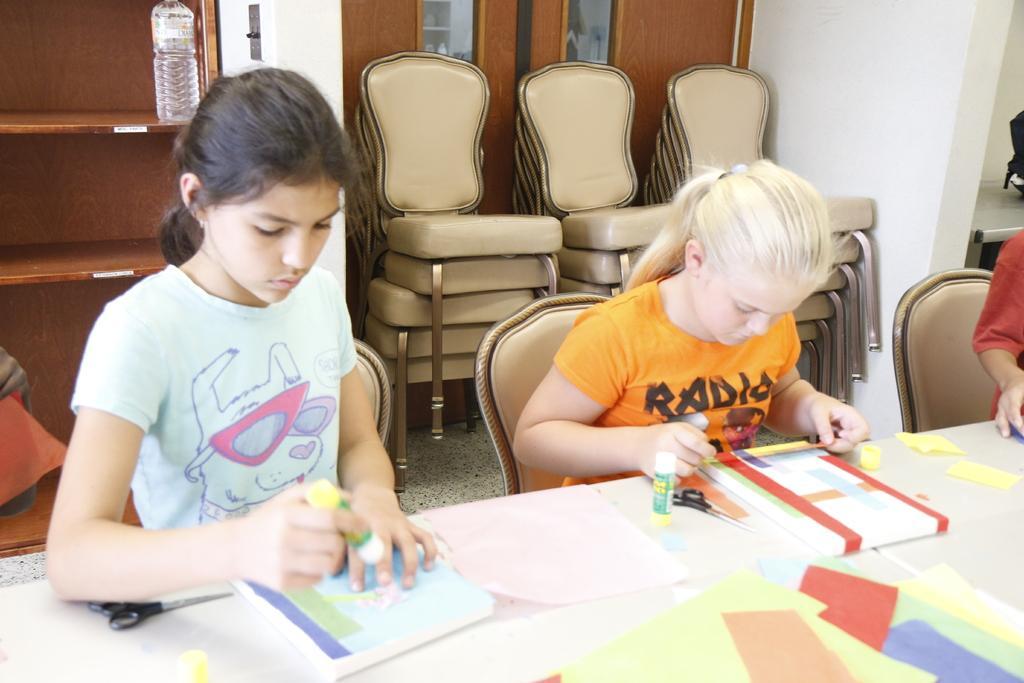How would you summarize this image in a sentence or two? there are two girls sitting on a chair and doing some work with a books on a table in front of them 